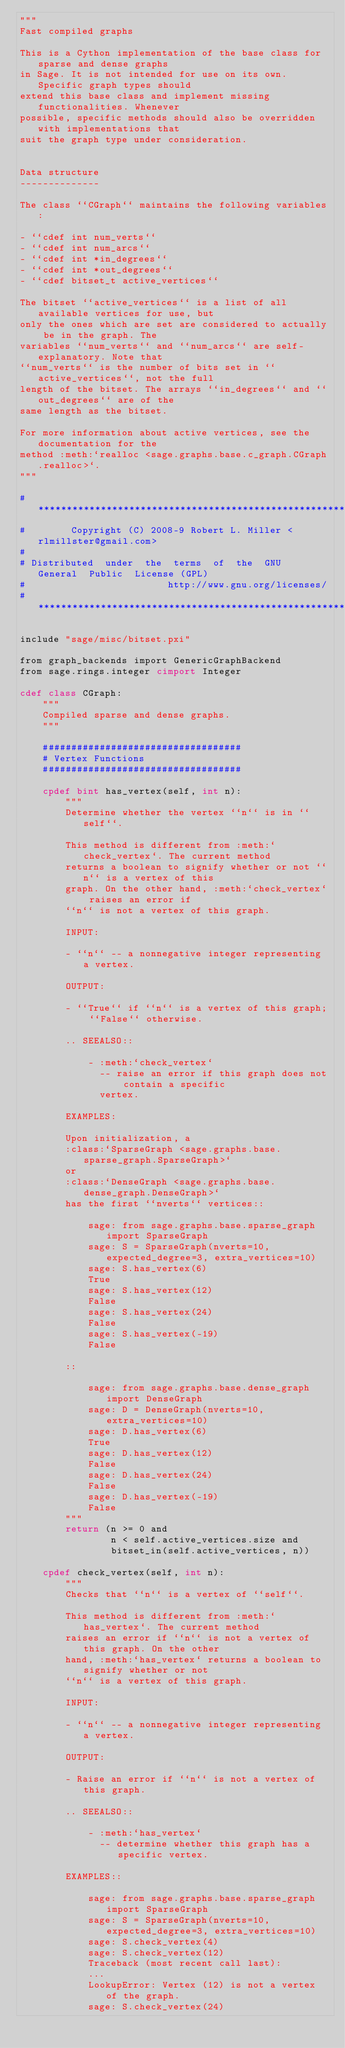Convert code to text. <code><loc_0><loc_0><loc_500><loc_500><_Cython_>"""
Fast compiled graphs

This is a Cython implementation of the base class for sparse and dense graphs
in Sage. It is not intended for use on its own. Specific graph types should
extend this base class and implement missing functionalities. Whenever
possible, specific methods should also be overridden with implementations that
suit the graph type under consideration.


Data structure
--------------

The class ``CGraph`` maintains the following variables:

- ``cdef int num_verts``
- ``cdef int num_arcs``
- ``cdef int *in_degrees``
- ``cdef int *out_degrees``
- ``cdef bitset_t active_vertices``

The bitset ``active_vertices`` is a list of all available vertices for use, but
only the ones which are set are considered to actually be in the graph. The
variables ``num_verts`` and ``num_arcs`` are self-explanatory. Note that
``num_verts`` is the number of bits set in ``active_vertices``, not the full
length of the bitset. The arrays ``in_degrees`` and ``out_degrees`` are of the
same length as the bitset.

For more information about active vertices, see the documentation for the
method :meth:`realloc <sage.graphs.base.c_graph.CGraph.realloc>`.
"""

#**************************************************************************
#        Copyright (C) 2008-9 Robert L. Miller <rlmillster@gmail.com>
#
# Distributed  under  the  terms  of  the  GNU  General  Public  License (GPL)
#                         http://www.gnu.org/licenses/
#**************************************************************************

include "sage/misc/bitset.pxi"

from graph_backends import GenericGraphBackend
from sage.rings.integer cimport Integer

cdef class CGraph:
    """
    Compiled sparse and dense graphs.
    """

    ###################################
    # Vertex Functions
    ###################################

    cpdef bint has_vertex(self, int n):
        """
        Determine whether the vertex ``n`` is in ``self``.

        This method is different from :meth:`check_vertex`. The current method
        returns a boolean to signify whether or not ``n`` is a vertex of this
        graph. On the other hand, :meth:`check_vertex` raises an error if
        ``n`` is not a vertex of this graph.

        INPUT:

        - ``n`` -- a nonnegative integer representing a vertex.

        OUTPUT:

        - ``True`` if ``n`` is a vertex of this graph; ``False`` otherwise.

        .. SEEALSO::

            - :meth:`check_vertex`
              -- raise an error if this graph does not contain a specific
              vertex.

        EXAMPLES:

        Upon initialization, a
        :class:`SparseGraph <sage.graphs.base.sparse_graph.SparseGraph>`
        or
        :class:`DenseGraph <sage.graphs.base.dense_graph.DenseGraph>`
        has the first ``nverts`` vertices::

            sage: from sage.graphs.base.sparse_graph import SparseGraph
            sage: S = SparseGraph(nverts=10, expected_degree=3, extra_vertices=10)
            sage: S.has_vertex(6)
            True
            sage: S.has_vertex(12)
            False
            sage: S.has_vertex(24)
            False
            sage: S.has_vertex(-19)
            False

        ::

            sage: from sage.graphs.base.dense_graph import DenseGraph
            sage: D = DenseGraph(nverts=10, extra_vertices=10)
            sage: D.has_vertex(6)
            True
            sage: D.has_vertex(12)
            False
            sage: D.has_vertex(24)
            False
            sage: D.has_vertex(-19)
            False
        """
        return (n >= 0 and
                n < self.active_vertices.size and
                bitset_in(self.active_vertices, n))

    cpdef check_vertex(self, int n):
        """
        Checks that ``n`` is a vertex of ``self``.

        This method is different from :meth:`has_vertex`. The current method
        raises an error if ``n`` is not a vertex of this graph. On the other
        hand, :meth:`has_vertex` returns a boolean to signify whether or not
        ``n`` is a vertex of this graph.

        INPUT:

        - ``n`` -- a nonnegative integer representing a vertex.

        OUTPUT:

        - Raise an error if ``n`` is not a vertex of this graph.

        .. SEEALSO::

            - :meth:`has_vertex`
              -- determine whether this graph has a specific vertex.

        EXAMPLES::

            sage: from sage.graphs.base.sparse_graph import SparseGraph
            sage: S = SparseGraph(nverts=10, expected_degree=3, extra_vertices=10)
            sage: S.check_vertex(4)
            sage: S.check_vertex(12)
            Traceback (most recent call last):
            ...
            LookupError: Vertex (12) is not a vertex of the graph.
            sage: S.check_vertex(24)</code> 